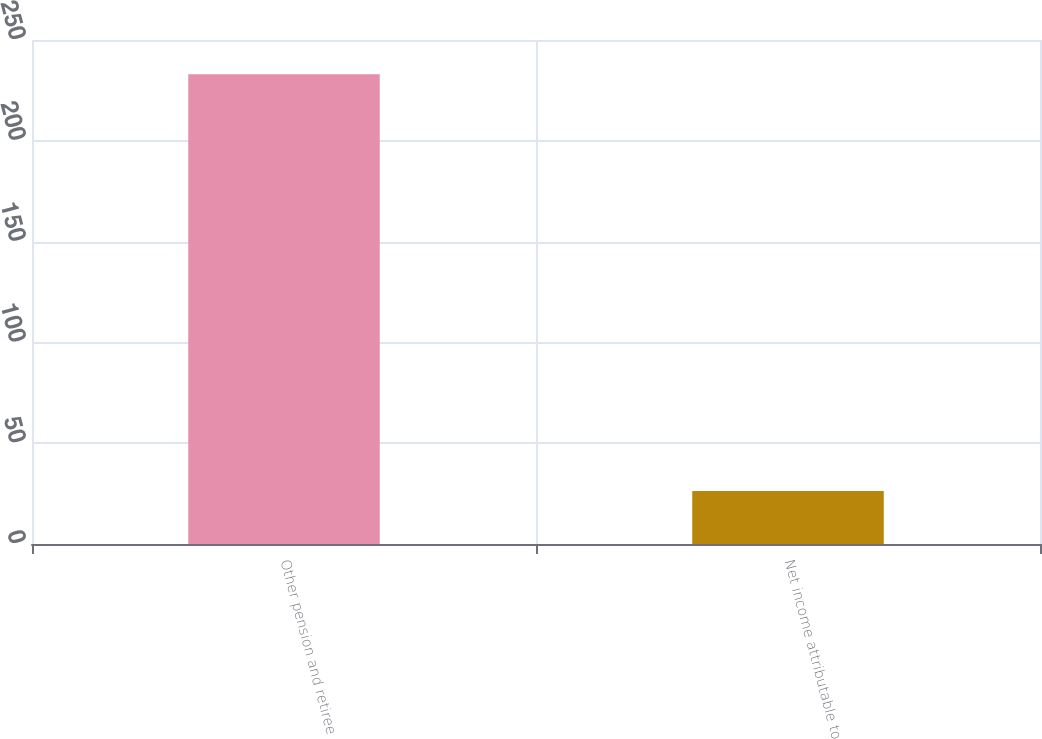<chart> <loc_0><loc_0><loc_500><loc_500><bar_chart><fcel>Other pension and retiree<fcel>Net income attributable to<nl><fcel>233<fcel>26.34<nl></chart> 